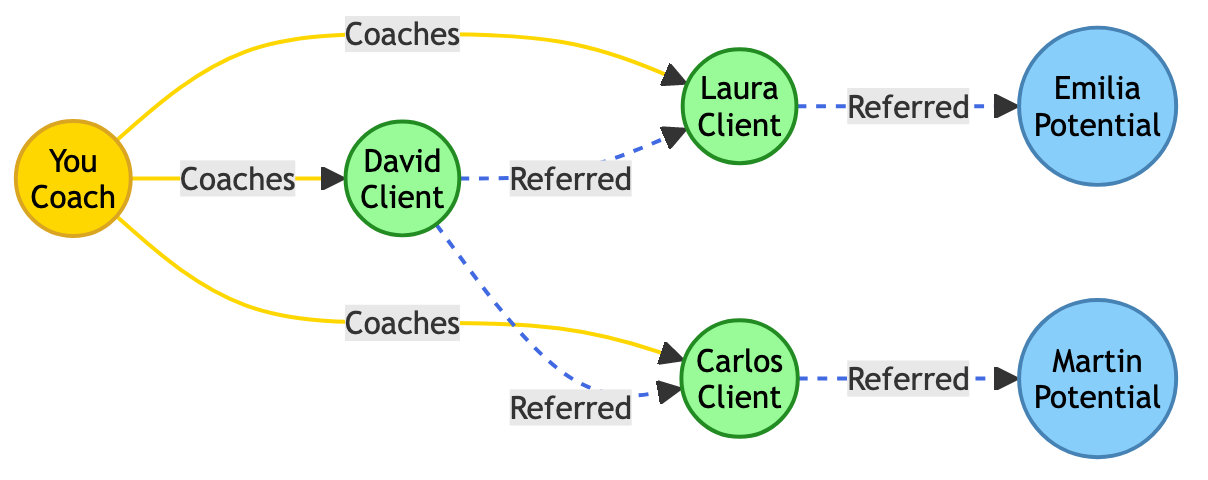What is the total number of clients in the network? There are three clients in the network: David, Laura, and Carlos. These are the entities with the type "Client" in the diagram.
Answer: 3 Who referred Laura? The diagram shows that David is the one who referred Laura, as indicated by the connection labeled "Referred" from David to Laura.
Answer: David Which type of node is Emilia? Emilia is categorized as a "Potential Client" in the diagram, as noted by the label above her node.
Answer: Potential Client How many referrals does Carlos have? Carlos has one referral, which is Martin. There is a direct connection labeled "Referred" from Carlos to Martin in the diagram.
Answer: 1 Which clients does David refer? David refers to two clients: Laura and Carlos, as shown by the connections "Referred" leading from David to both Laura and Carlos.
Answer: Laura and Carlos Who is the coach of Laura? According to the diagram, you (the Coach) are the one who coaches Laura, as indicated by the connection labeled "Coaches" from you to Laura.
Answer: You What is the relationship between Laura and Emilia? The relationship between Laura and Emilia is that Laura referred Emilia, as shown by the arrow labeled "Referred" pointing from Laura to Emilia.
Answer: Referred How many connections do you have to clients? You have three connections to clients, which are to David, Laura, and Carlos, as shown by the three "Coaches" connections.
Answer: 3 Which potential client is referred by Carlos? Carlos refers to one potential client named Martin, indicated by the connection labeled "Referred" from Carlos to Martin.
Answer: Martin 